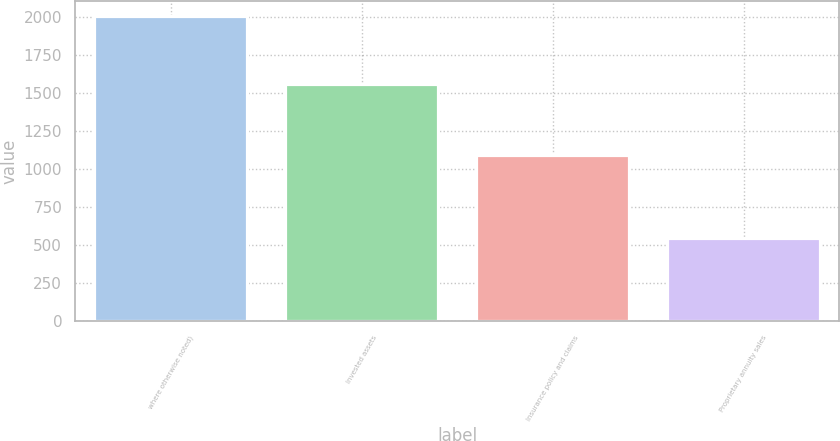Convert chart to OTSL. <chart><loc_0><loc_0><loc_500><loc_500><bar_chart><fcel>where otherwise noted)<fcel>Invested assets<fcel>Insurance policy and claims<fcel>Proprietary annuity sales<nl><fcel>2003<fcel>1559<fcel>1096<fcel>548<nl></chart> 